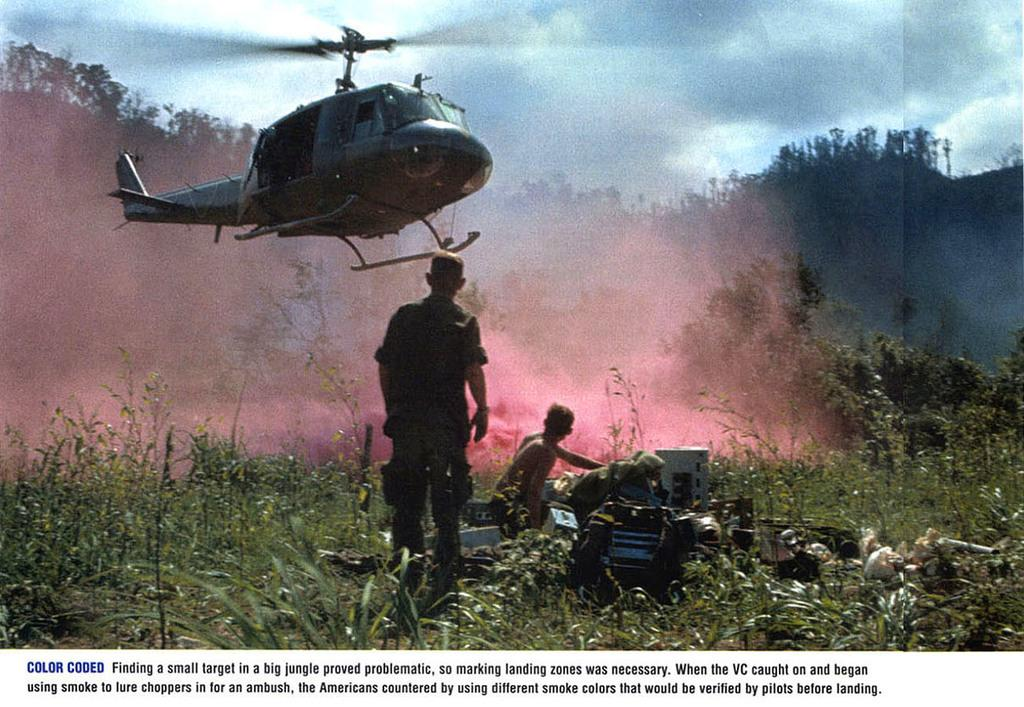<image>
Provide a brief description of the given image. An image shows soldiers in a field with a helicopter about to land with a caption describing how colored smoke is used by the military. 